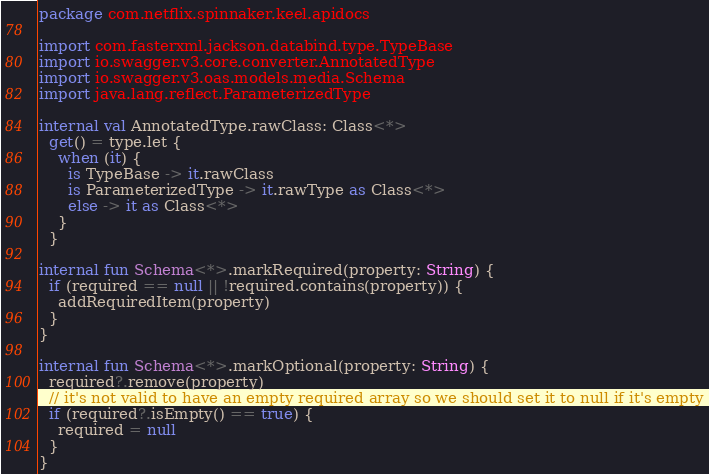Convert code to text. <code><loc_0><loc_0><loc_500><loc_500><_Kotlin_>package com.netflix.spinnaker.keel.apidocs

import com.fasterxml.jackson.databind.type.TypeBase
import io.swagger.v3.core.converter.AnnotatedType
import io.swagger.v3.oas.models.media.Schema
import java.lang.reflect.ParameterizedType

internal val AnnotatedType.rawClass: Class<*>
  get() = type.let {
    when (it) {
      is TypeBase -> it.rawClass
      is ParameterizedType -> it.rawType as Class<*>
      else -> it as Class<*>
    }
  }

internal fun Schema<*>.markRequired(property: String) {
  if (required == null || !required.contains(property)) {
    addRequiredItem(property)
  }
}

internal fun Schema<*>.markOptional(property: String) {
  required?.remove(property)
  // it's not valid to have an empty required array so we should set it to null if it's empty
  if (required?.isEmpty() == true) {
    required = null
  }
}
</code> 